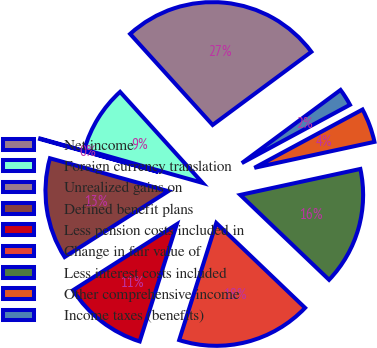Convert chart to OTSL. <chart><loc_0><loc_0><loc_500><loc_500><pie_chart><fcel>Net income<fcel>Foreign currency translation<fcel>Unrealized gains on<fcel>Defined benefit plans<fcel>Less pension costs included in<fcel>Change in fair value of<fcel>Less interest costs included<fcel>Other comprehensive income<fcel>Income taxes (benefits)<nl><fcel>26.57%<fcel>8.9%<fcel>0.07%<fcel>13.32%<fcel>11.11%<fcel>17.74%<fcel>15.53%<fcel>4.48%<fcel>2.28%<nl></chart> 